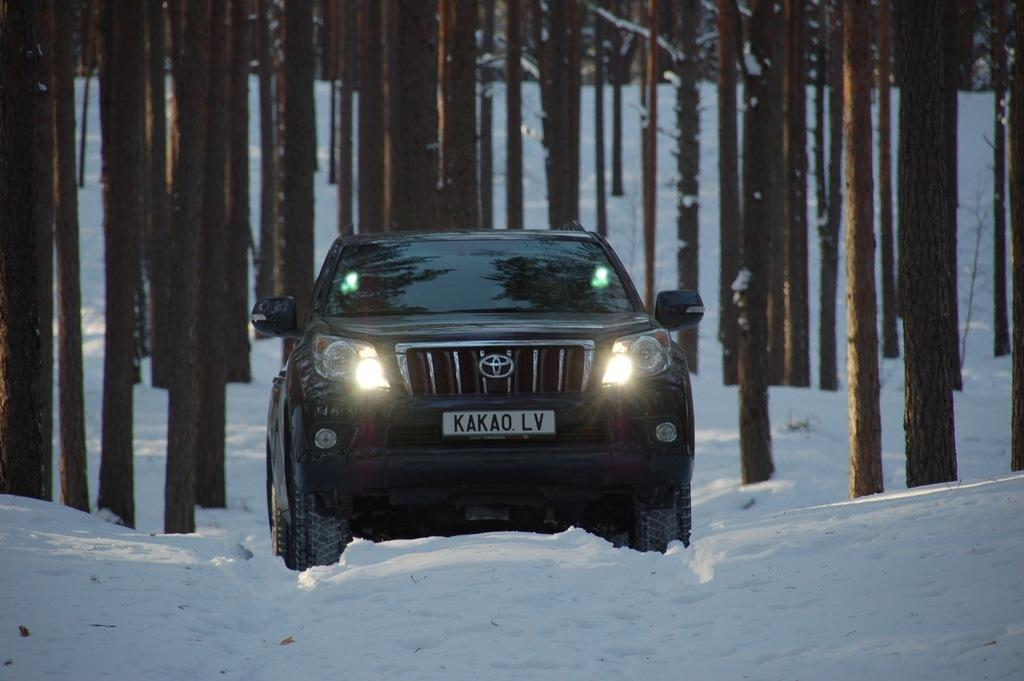What type of vehicle is in the middle of the picture? There is a black car in the middle of the picture. What is present at the bottom of the image? There is ice at the bottom of the image. What can be seen in the background of the picture? The stems of the trees are visible in the background. How are the trees affected by the ice? The trees are covered with ice. What type of vest is the car wearing in the image? Cars do not wear vests; the question is not applicable to the image. 